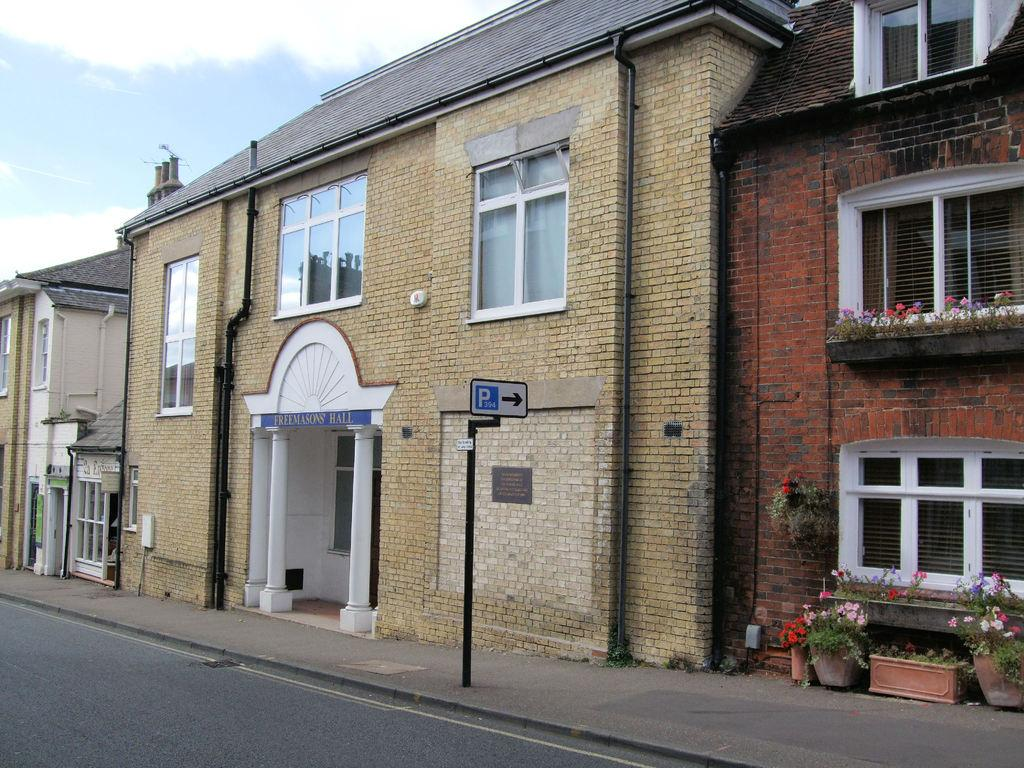What type of structures can be seen in the image? There are buildings in the image. What else can be seen in the image besides the buildings? Pipelines, a name board, a sign board, house plants, and windows are visible in the image. What is the purpose of the name board and sign board in the image? The name board and sign board provide information or identification for the buildings or location. What is visible in the background of the image? The sky is visible in the background of the image. Where is the faucet located in the image? There is no faucet present in the image. What type of plantation can be seen in the image? There is no plantation present in the image. 